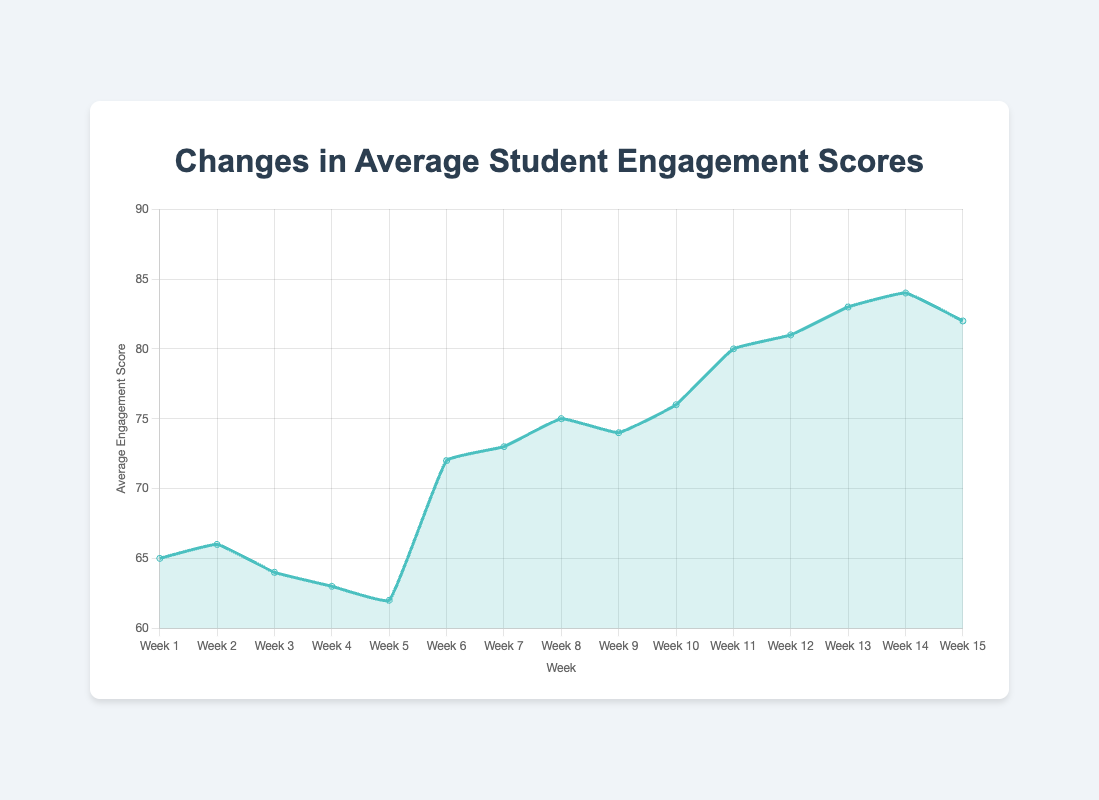What is the trend in the Average Engagement Score for the Traditional Lecture method from Week 1 to Week 5? Initially, the Average Engagement Score begins at 65 in Week 1 and gradually decreases each subsequent week, reaching 62 by Week 5. This shows a downward trend in engagement for this period.
Answer: Decreasing What is the overall change in Average Engagement Score from Week 6 to Week 10 when using the Interactive Lecture method? The score increases from 72 in Week 6 to 76 in Week 10. The overall change is calculated as 76 - 72 = 4.
Answer: 4 During which period is the steepest increase in Average Engagement Score observed, and what is the score change? The steepest increase is observed between Week 10 (Interactive Lecture) and Week 11 (Problem-Based Learning). The score increases from 76 to 80, which is a change of 80 - 76 = 4.
Answer: Weeks 10 to 11, 4 How does the Average Engagement Score in Week 15 compare to the Average Engagement Score in Week 1? The score in Week 15 (Problem-Based Learning) is 82, which is significantly higher than the score in Week 1 (Traditional Lecture), which is 65. The difference is 82 - 65 = 17.
Answer: 17 higher During what weeks does the Average Engagement Score remain relatively stable, having minor fluctuations? Between Weeks 6 and 10 (Interactive Lecture), the score has minor fluctuations around 72 and 76, staying relatively stable.
Answer: Weeks 6 to 10 When does the Average Engagement Score first reach 80? The score first reaches 80 during Week 11 when Problem-Based Learning is used as the teaching method.
Answer: Week 11 In which week does the Average Engagement Score peak, and what is the value? The peak occurs in Week 14 with an Average Engagement Score of 84.
Answer: Week 14, 84 What is the difference in Average Engagement Score between the last week of Traditional Lecture and the first week of Interactive Lecture? The score in the last week of Traditional Lecture (Week 5) is 62, and the first week of Interactive Lecture (Week 6) is 72. The difference is 72 - 62 = 10.
Answer: 10 What teaching method shows the highest peak in Average Engagement Score across all weeks? Problem-Based Learning shows the highest peak with a score of 84 in Week 14.
Answer: Problem-Based Learning 